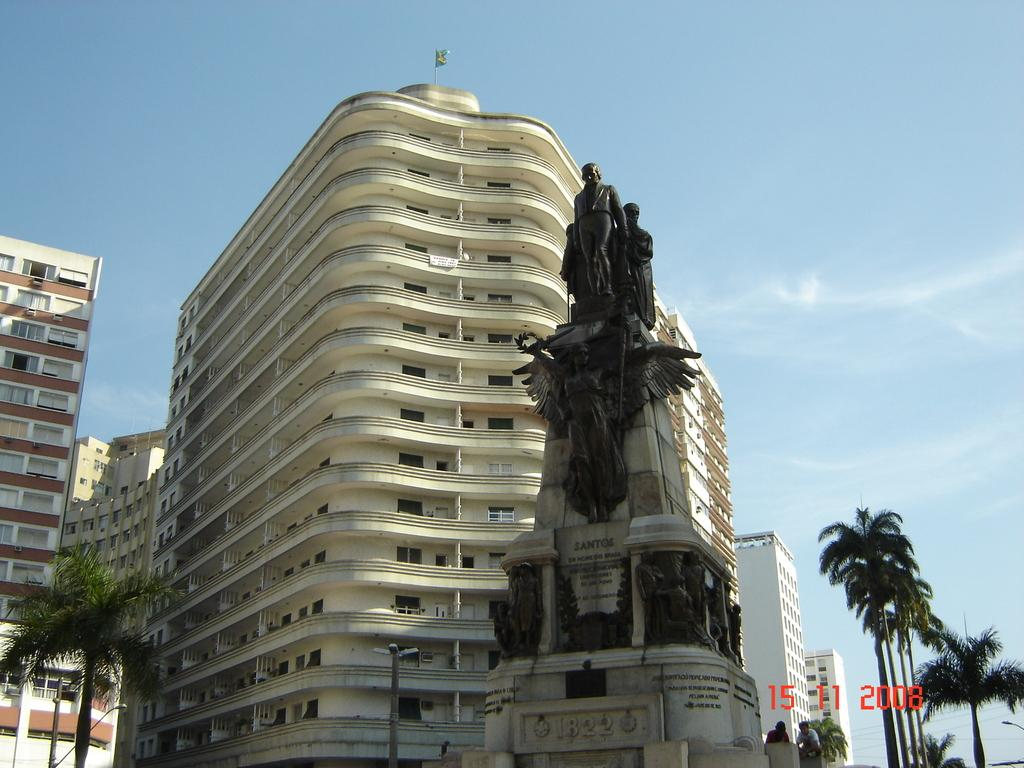Provide a one-sentence caption for the provided image. Statue with the year 1822 near the bottome next to a building. 